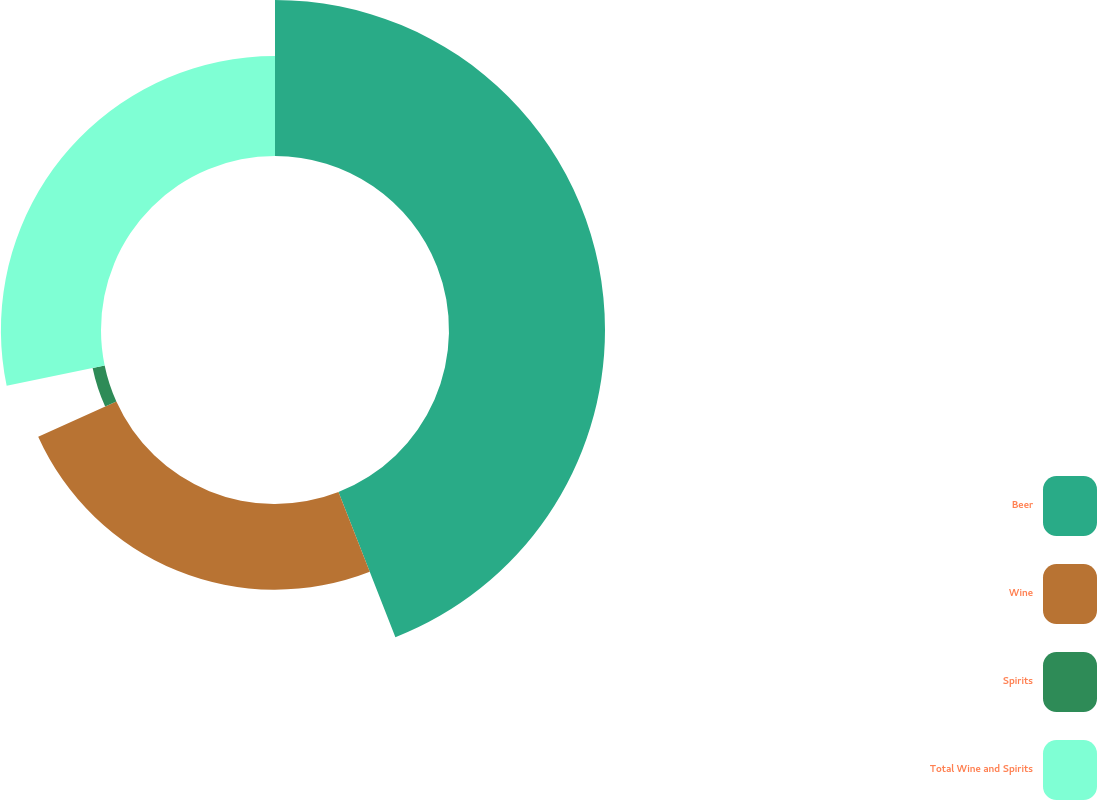Convert chart to OTSL. <chart><loc_0><loc_0><loc_500><loc_500><pie_chart><fcel>Beer<fcel>Wine<fcel>Spirits<fcel>Total Wine and Spirits<nl><fcel>44.06%<fcel>24.21%<fcel>3.47%<fcel>28.27%<nl></chart> 